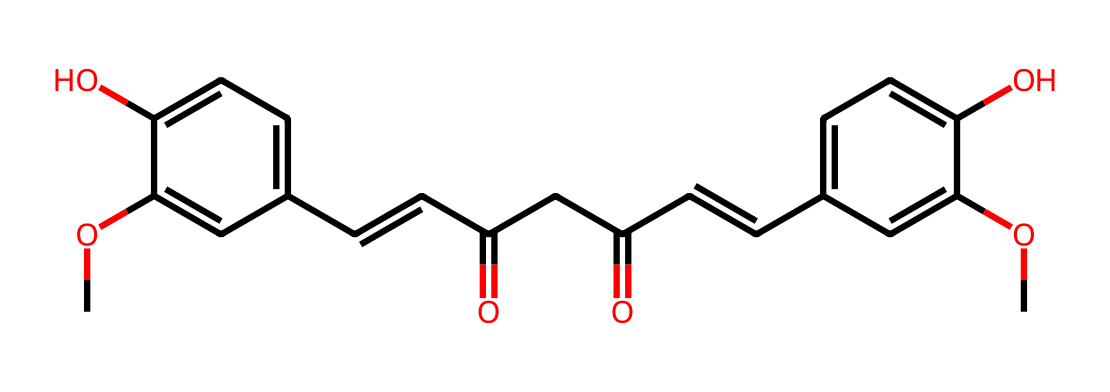What is the main functional group present in curcumin? The chemical structure shows multiple hydroxyl (–OH) groups attached to the aromatic rings, indicating that curcumin has phenolic functional groups.
Answer: phenolic group How many rings are in the structure of curcumin? Observing the structure reveals a total of two aromatic rings present within the molecule, indicated by the fused benzene-like portions.
Answer: two What is the total number of carbon atoms in curcumin? By counting the carbon atoms represented in the SMILES structure, including those in the side chains, we find there are a total of 21 carbon atoms.
Answer: 21 Does curcumin have any double bonds? The representation indicates the presence of multiple double bonds, specifically in the α,β-unsaturated carbonyl and alkene regions in the structure.
Answer: yes What type of compound is curcumin classified as? Based on the structural analysis and the presence of multiple hydroxyl groups, conjugated double bonds, and aromatic rings, curcumin is classified as a diarylheptanoid.
Answer: diarylheptanoid How many methoxy groups are present in curcumin? The structure displays two –OCH3 groups, which are typical methoxy groups attached to the aromatic rings of curcumin.
Answer: two 